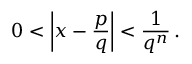<formula> <loc_0><loc_0><loc_500><loc_500>0 < \left | x - { \frac { p } { q } } \right | < { \frac { 1 } { q ^ { n } } } \, .</formula> 